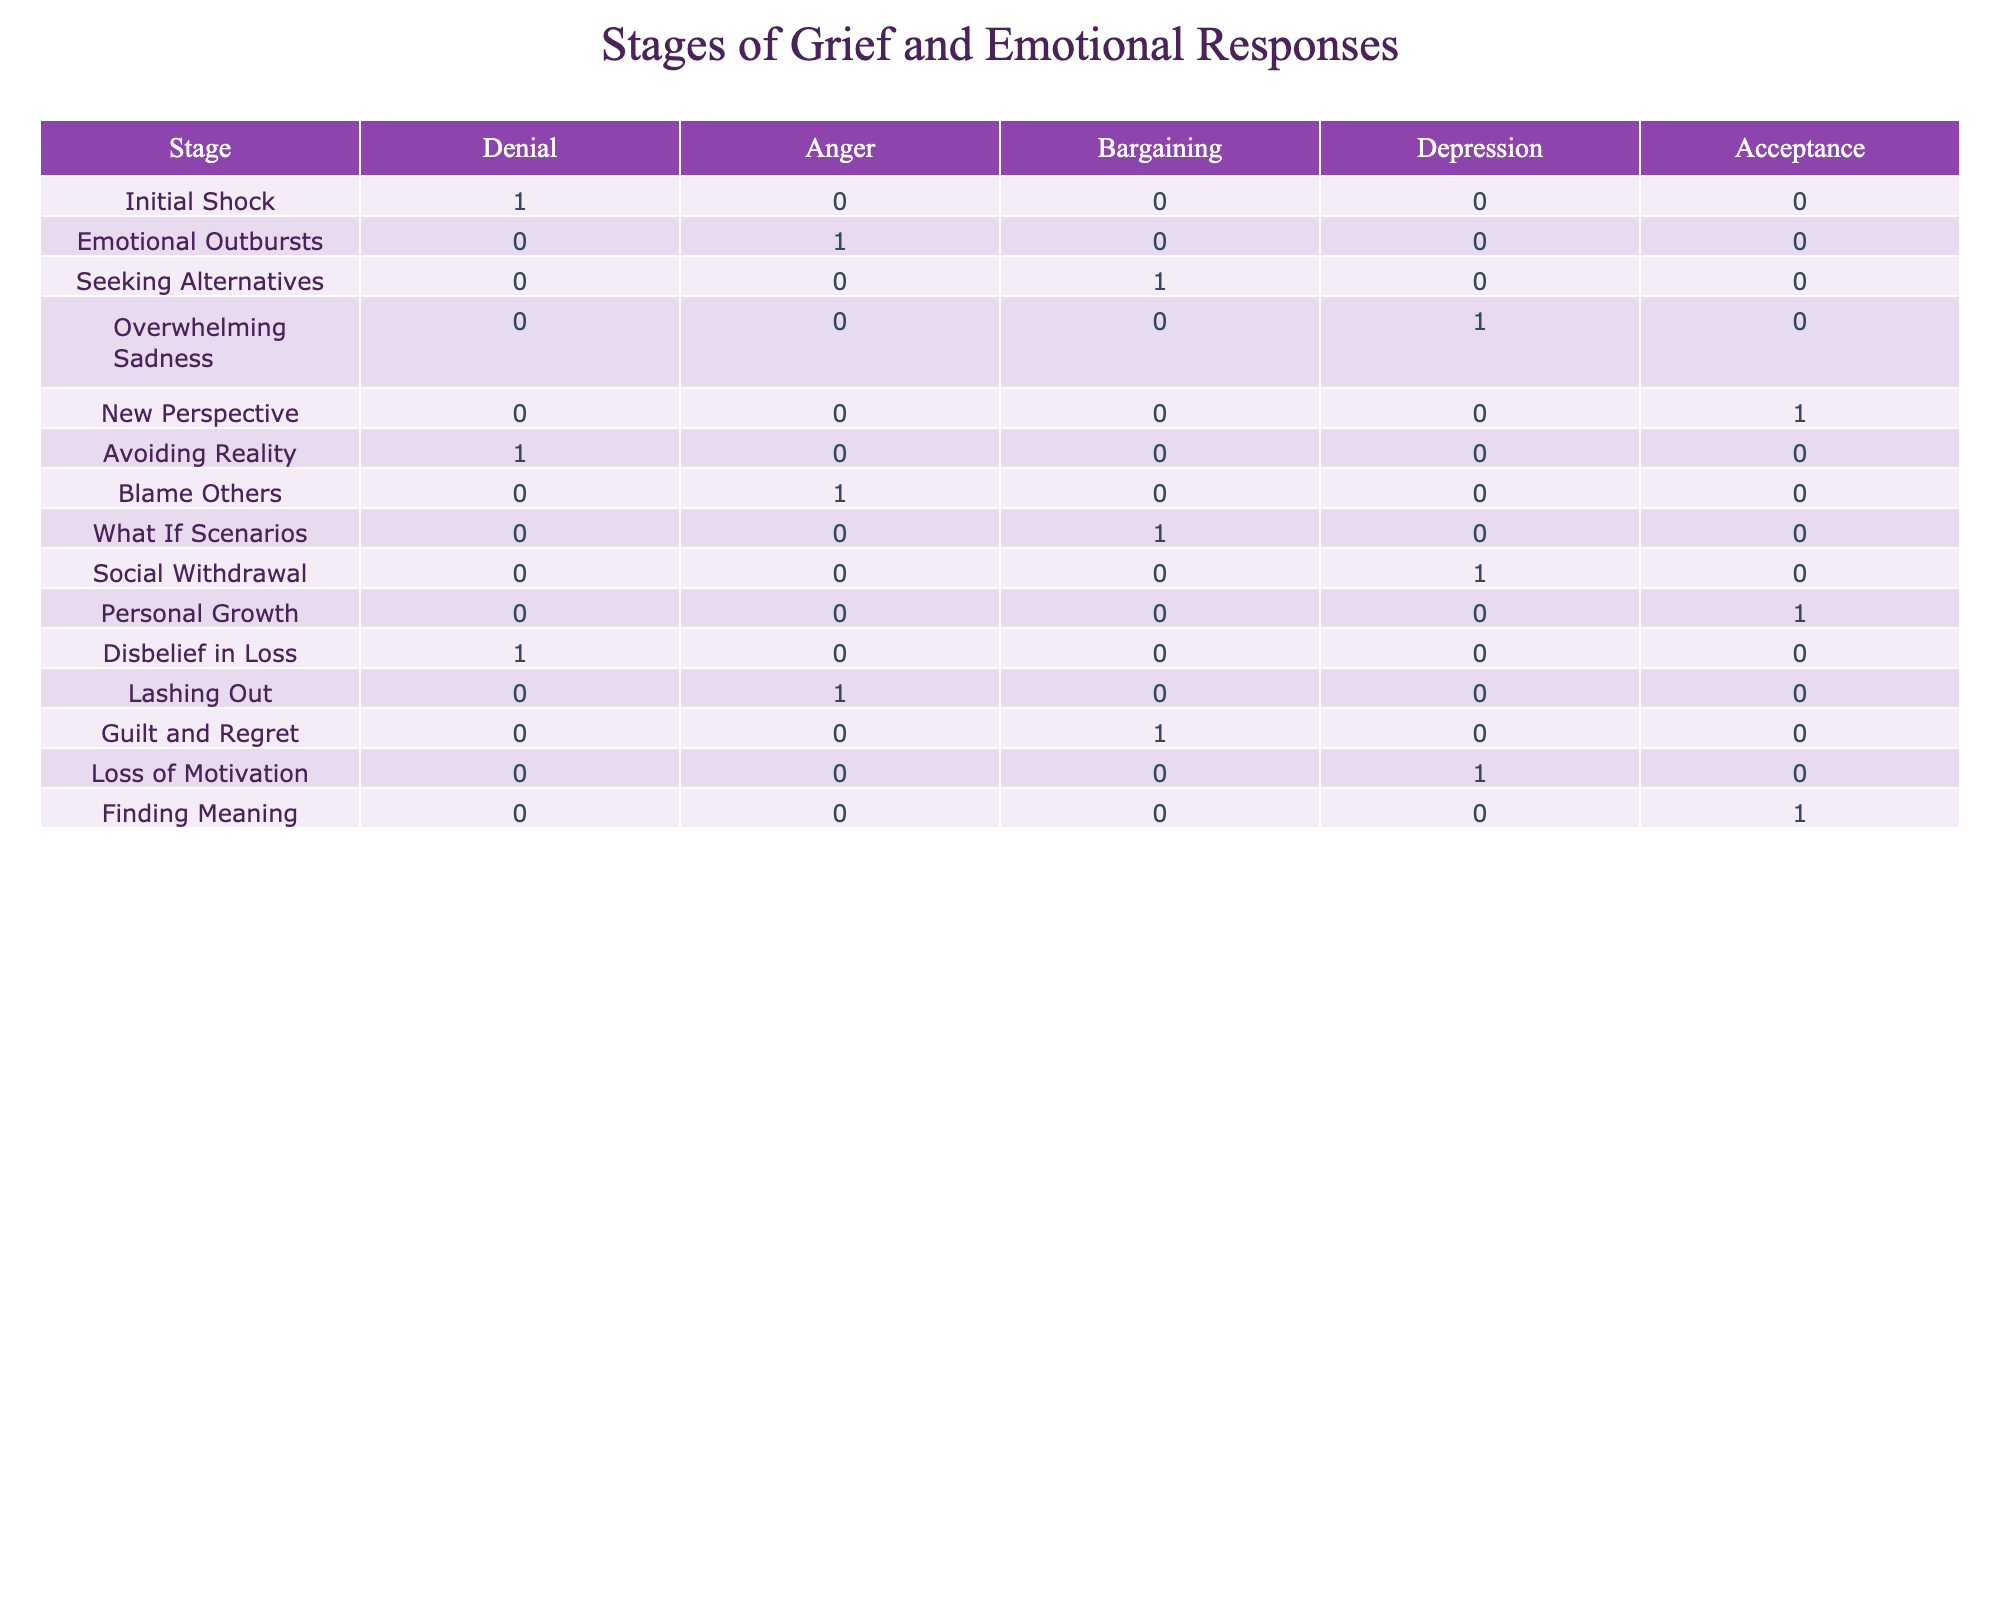What stage of grief is associated with overwhelming sadness? The table indicates that "Overwhelming Sadness" corresponds to the "Depression" stage of grief, where the emotional response is true for this stage.
Answer: Depression Are there more emotional responses related to anger than to denial? The table shows that "Anger" appears in three instances (Emotional Outbursts, Blame Others, Lashing Out), while "Denial" only appears in two instances (Initial Shock, Avoiding Reality). Therefore, there are more emotional responses related to anger.
Answer: Yes Does seeking alternatives occur in the acceptance stage? The table indicates that "Seeking Alternatives" relates to the "Bargaining" stage rather than the "Acceptance" stage, which shows a true emotional response for personal growth.
Answer: No How many emotional responses are associated with the denial stage? The table lists three instances associated with "Denial" (Initial Shock, Avoiding Reality, Disbelief in Loss). Counting these gives a total of three emotional responses.
Answer: 3 Which stages correspond with finding meaning? The table shows that "Finding Meaning" corresponds to the "Acceptance" stage of grief, where the emotional response is true.
Answer: Acceptance If we sum up the emotional responses that are true for the depression and acceptance stages, what is the total number of responses? The "Depression" stage corresponds to "Overwhelming Sadness" (1 response), and the "Acceptance" stage corresponds to "New Perspective" and "Finding Meaning" (2 responses). Adding these gives a total of 1 + 2 = 3 responses.
Answer: 3 What is the emotional response for the initial shock stage? According to the table, the emotional response for "Initial Shock" is "Denial," which is marked as true in this stage.
Answer: Denial Is there an emotional response for blame others in the bargaining stage? The table shows that "Blame Others" falls under the "Anger" stage, not the "Bargaining" stage, which corresponds to "Seeking Alternatives" as true.
Answer: No 